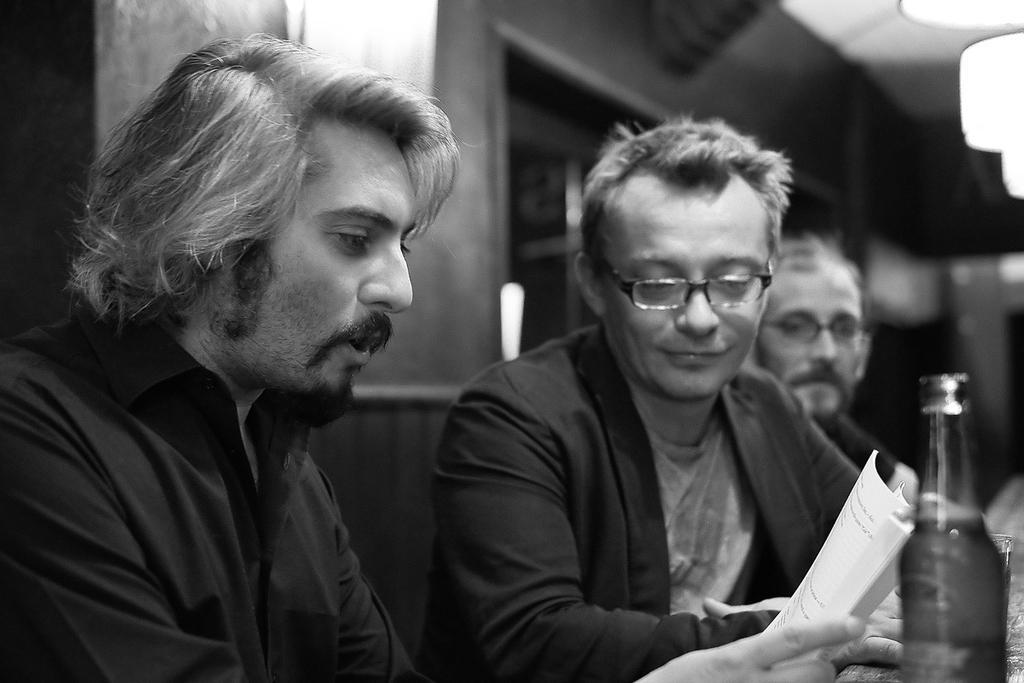Could you give a brief overview of what you see in this image? In this picture we can see three men sitting and one is holding paper in his hand and in front of them we can see bottle, glass and in background we can see wall. 